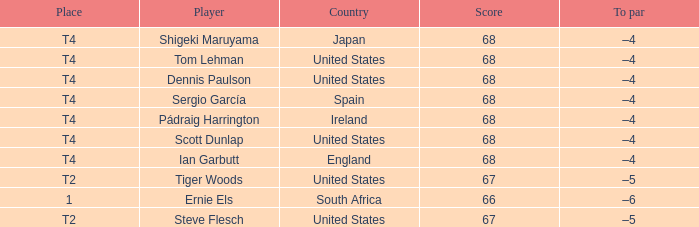What is the Place of the Player with a Score of 67? T2, T2. 